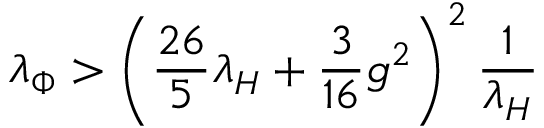Convert formula to latex. <formula><loc_0><loc_0><loc_500><loc_500>\lambda _ { \Phi } > \left ( { \frac { 2 6 } { 5 } } \lambda _ { H } + { \frac { 3 } { 1 6 } } g ^ { 2 } \right ) ^ { 2 } { \frac { 1 } { \lambda _ { H } } }</formula> 